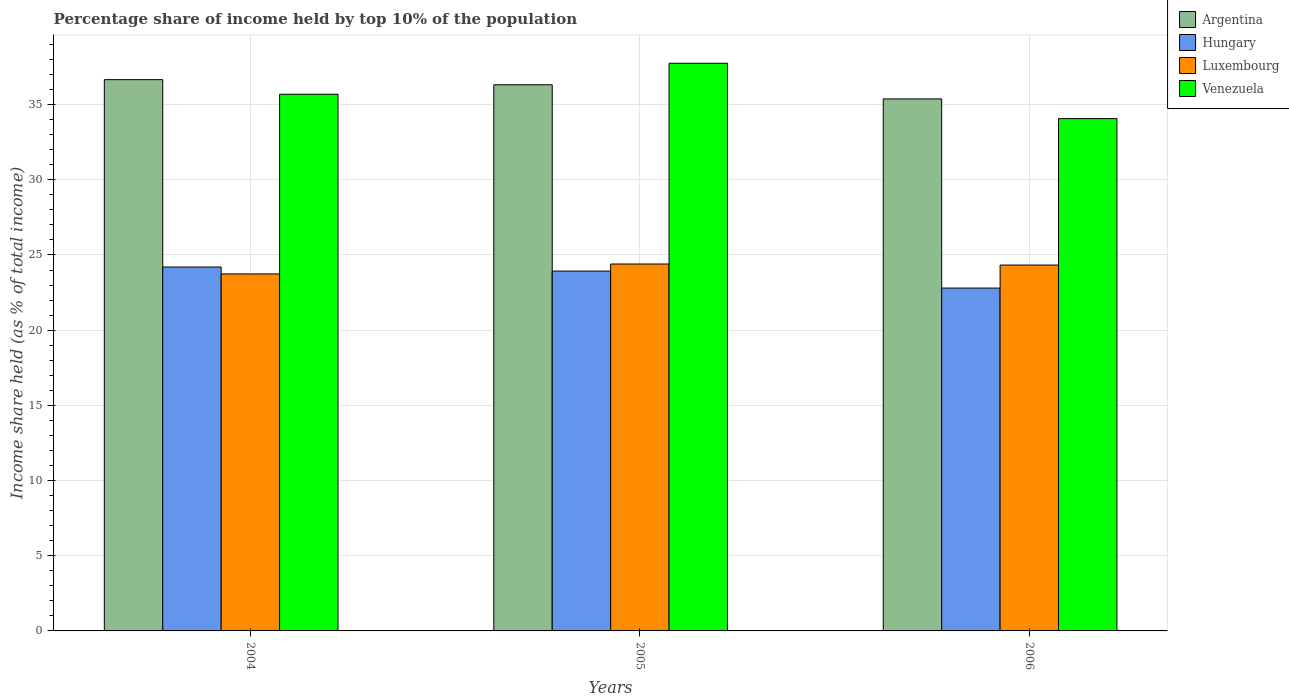How many groups of bars are there?
Provide a short and direct response. 3. Are the number of bars per tick equal to the number of legend labels?
Your response must be concise. Yes. What is the label of the 3rd group of bars from the left?
Keep it short and to the point. 2006. In how many cases, is the number of bars for a given year not equal to the number of legend labels?
Your answer should be very brief. 0. What is the percentage share of income held by top 10% of the population in Venezuela in 2004?
Ensure brevity in your answer.  35.69. Across all years, what is the maximum percentage share of income held by top 10% of the population in Hungary?
Offer a terse response. 24.2. Across all years, what is the minimum percentage share of income held by top 10% of the population in Argentina?
Ensure brevity in your answer.  35.38. What is the total percentage share of income held by top 10% of the population in Hungary in the graph?
Ensure brevity in your answer.  70.93. What is the difference between the percentage share of income held by top 10% of the population in Luxembourg in 2004 and that in 2005?
Provide a short and direct response. -0.66. What is the difference between the percentage share of income held by top 10% of the population in Venezuela in 2005 and the percentage share of income held by top 10% of the population in Hungary in 2004?
Give a very brief answer. 13.55. What is the average percentage share of income held by top 10% of the population in Hungary per year?
Your response must be concise. 23.64. In the year 2005, what is the difference between the percentage share of income held by top 10% of the population in Luxembourg and percentage share of income held by top 10% of the population in Argentina?
Give a very brief answer. -11.92. What is the ratio of the percentage share of income held by top 10% of the population in Venezuela in 2005 to that in 2006?
Provide a succinct answer. 1.11. Is the difference between the percentage share of income held by top 10% of the population in Luxembourg in 2004 and 2006 greater than the difference between the percentage share of income held by top 10% of the population in Argentina in 2004 and 2006?
Your response must be concise. No. What is the difference between the highest and the second highest percentage share of income held by top 10% of the population in Argentina?
Your answer should be compact. 0.34. What is the difference between the highest and the lowest percentage share of income held by top 10% of the population in Venezuela?
Provide a short and direct response. 3.68. In how many years, is the percentage share of income held by top 10% of the population in Argentina greater than the average percentage share of income held by top 10% of the population in Argentina taken over all years?
Your answer should be very brief. 2. Is the sum of the percentage share of income held by top 10% of the population in Venezuela in 2005 and 2006 greater than the maximum percentage share of income held by top 10% of the population in Argentina across all years?
Make the answer very short. Yes. What does the 4th bar from the left in 2006 represents?
Make the answer very short. Venezuela. What does the 2nd bar from the right in 2005 represents?
Provide a short and direct response. Luxembourg. Is it the case that in every year, the sum of the percentage share of income held by top 10% of the population in Argentina and percentage share of income held by top 10% of the population in Luxembourg is greater than the percentage share of income held by top 10% of the population in Hungary?
Give a very brief answer. Yes. Are all the bars in the graph horizontal?
Your answer should be compact. No. Does the graph contain grids?
Ensure brevity in your answer.  Yes. How many legend labels are there?
Give a very brief answer. 4. How are the legend labels stacked?
Make the answer very short. Vertical. What is the title of the graph?
Ensure brevity in your answer.  Percentage share of income held by top 10% of the population. What is the label or title of the Y-axis?
Offer a terse response. Income share held (as % of total income). What is the Income share held (as % of total income) of Argentina in 2004?
Make the answer very short. 36.66. What is the Income share held (as % of total income) in Hungary in 2004?
Offer a very short reply. 24.2. What is the Income share held (as % of total income) in Luxembourg in 2004?
Give a very brief answer. 23.74. What is the Income share held (as % of total income) in Venezuela in 2004?
Offer a very short reply. 35.69. What is the Income share held (as % of total income) in Argentina in 2005?
Provide a succinct answer. 36.32. What is the Income share held (as % of total income) of Hungary in 2005?
Provide a succinct answer. 23.93. What is the Income share held (as % of total income) in Luxembourg in 2005?
Offer a very short reply. 24.4. What is the Income share held (as % of total income) of Venezuela in 2005?
Give a very brief answer. 37.75. What is the Income share held (as % of total income) of Argentina in 2006?
Your answer should be compact. 35.38. What is the Income share held (as % of total income) in Hungary in 2006?
Provide a succinct answer. 22.8. What is the Income share held (as % of total income) in Luxembourg in 2006?
Give a very brief answer. 24.33. What is the Income share held (as % of total income) in Venezuela in 2006?
Offer a very short reply. 34.07. Across all years, what is the maximum Income share held (as % of total income) of Argentina?
Your answer should be very brief. 36.66. Across all years, what is the maximum Income share held (as % of total income) in Hungary?
Provide a succinct answer. 24.2. Across all years, what is the maximum Income share held (as % of total income) of Luxembourg?
Your response must be concise. 24.4. Across all years, what is the maximum Income share held (as % of total income) of Venezuela?
Your answer should be very brief. 37.75. Across all years, what is the minimum Income share held (as % of total income) in Argentina?
Your answer should be compact. 35.38. Across all years, what is the minimum Income share held (as % of total income) in Hungary?
Your answer should be very brief. 22.8. Across all years, what is the minimum Income share held (as % of total income) of Luxembourg?
Offer a very short reply. 23.74. Across all years, what is the minimum Income share held (as % of total income) in Venezuela?
Give a very brief answer. 34.07. What is the total Income share held (as % of total income) in Argentina in the graph?
Your answer should be very brief. 108.36. What is the total Income share held (as % of total income) of Hungary in the graph?
Offer a very short reply. 70.93. What is the total Income share held (as % of total income) in Luxembourg in the graph?
Your response must be concise. 72.47. What is the total Income share held (as % of total income) of Venezuela in the graph?
Your response must be concise. 107.51. What is the difference between the Income share held (as % of total income) in Argentina in 2004 and that in 2005?
Offer a terse response. 0.34. What is the difference between the Income share held (as % of total income) of Hungary in 2004 and that in 2005?
Give a very brief answer. 0.27. What is the difference between the Income share held (as % of total income) in Luxembourg in 2004 and that in 2005?
Provide a succinct answer. -0.66. What is the difference between the Income share held (as % of total income) of Venezuela in 2004 and that in 2005?
Your answer should be very brief. -2.06. What is the difference between the Income share held (as % of total income) of Argentina in 2004 and that in 2006?
Give a very brief answer. 1.28. What is the difference between the Income share held (as % of total income) of Luxembourg in 2004 and that in 2006?
Make the answer very short. -0.59. What is the difference between the Income share held (as % of total income) of Venezuela in 2004 and that in 2006?
Offer a very short reply. 1.62. What is the difference between the Income share held (as % of total income) of Hungary in 2005 and that in 2006?
Offer a terse response. 1.13. What is the difference between the Income share held (as % of total income) in Luxembourg in 2005 and that in 2006?
Ensure brevity in your answer.  0.07. What is the difference between the Income share held (as % of total income) of Venezuela in 2005 and that in 2006?
Make the answer very short. 3.68. What is the difference between the Income share held (as % of total income) in Argentina in 2004 and the Income share held (as % of total income) in Hungary in 2005?
Ensure brevity in your answer.  12.73. What is the difference between the Income share held (as % of total income) in Argentina in 2004 and the Income share held (as % of total income) in Luxembourg in 2005?
Your response must be concise. 12.26. What is the difference between the Income share held (as % of total income) of Argentina in 2004 and the Income share held (as % of total income) of Venezuela in 2005?
Your answer should be compact. -1.09. What is the difference between the Income share held (as % of total income) in Hungary in 2004 and the Income share held (as % of total income) in Luxembourg in 2005?
Make the answer very short. -0.2. What is the difference between the Income share held (as % of total income) in Hungary in 2004 and the Income share held (as % of total income) in Venezuela in 2005?
Provide a short and direct response. -13.55. What is the difference between the Income share held (as % of total income) of Luxembourg in 2004 and the Income share held (as % of total income) of Venezuela in 2005?
Your answer should be very brief. -14.01. What is the difference between the Income share held (as % of total income) in Argentina in 2004 and the Income share held (as % of total income) in Hungary in 2006?
Your answer should be very brief. 13.86. What is the difference between the Income share held (as % of total income) of Argentina in 2004 and the Income share held (as % of total income) of Luxembourg in 2006?
Offer a terse response. 12.33. What is the difference between the Income share held (as % of total income) in Argentina in 2004 and the Income share held (as % of total income) in Venezuela in 2006?
Provide a short and direct response. 2.59. What is the difference between the Income share held (as % of total income) of Hungary in 2004 and the Income share held (as % of total income) of Luxembourg in 2006?
Make the answer very short. -0.13. What is the difference between the Income share held (as % of total income) in Hungary in 2004 and the Income share held (as % of total income) in Venezuela in 2006?
Keep it short and to the point. -9.87. What is the difference between the Income share held (as % of total income) in Luxembourg in 2004 and the Income share held (as % of total income) in Venezuela in 2006?
Give a very brief answer. -10.33. What is the difference between the Income share held (as % of total income) of Argentina in 2005 and the Income share held (as % of total income) of Hungary in 2006?
Provide a short and direct response. 13.52. What is the difference between the Income share held (as % of total income) of Argentina in 2005 and the Income share held (as % of total income) of Luxembourg in 2006?
Offer a terse response. 11.99. What is the difference between the Income share held (as % of total income) in Argentina in 2005 and the Income share held (as % of total income) in Venezuela in 2006?
Provide a short and direct response. 2.25. What is the difference between the Income share held (as % of total income) in Hungary in 2005 and the Income share held (as % of total income) in Venezuela in 2006?
Your answer should be very brief. -10.14. What is the difference between the Income share held (as % of total income) of Luxembourg in 2005 and the Income share held (as % of total income) of Venezuela in 2006?
Give a very brief answer. -9.67. What is the average Income share held (as % of total income) of Argentina per year?
Give a very brief answer. 36.12. What is the average Income share held (as % of total income) of Hungary per year?
Your response must be concise. 23.64. What is the average Income share held (as % of total income) in Luxembourg per year?
Your answer should be compact. 24.16. What is the average Income share held (as % of total income) of Venezuela per year?
Your answer should be compact. 35.84. In the year 2004, what is the difference between the Income share held (as % of total income) in Argentina and Income share held (as % of total income) in Hungary?
Provide a short and direct response. 12.46. In the year 2004, what is the difference between the Income share held (as % of total income) of Argentina and Income share held (as % of total income) of Luxembourg?
Your response must be concise. 12.92. In the year 2004, what is the difference between the Income share held (as % of total income) in Hungary and Income share held (as % of total income) in Luxembourg?
Keep it short and to the point. 0.46. In the year 2004, what is the difference between the Income share held (as % of total income) of Hungary and Income share held (as % of total income) of Venezuela?
Ensure brevity in your answer.  -11.49. In the year 2004, what is the difference between the Income share held (as % of total income) in Luxembourg and Income share held (as % of total income) in Venezuela?
Keep it short and to the point. -11.95. In the year 2005, what is the difference between the Income share held (as % of total income) in Argentina and Income share held (as % of total income) in Hungary?
Your response must be concise. 12.39. In the year 2005, what is the difference between the Income share held (as % of total income) of Argentina and Income share held (as % of total income) of Luxembourg?
Offer a very short reply. 11.92. In the year 2005, what is the difference between the Income share held (as % of total income) of Argentina and Income share held (as % of total income) of Venezuela?
Make the answer very short. -1.43. In the year 2005, what is the difference between the Income share held (as % of total income) in Hungary and Income share held (as % of total income) in Luxembourg?
Keep it short and to the point. -0.47. In the year 2005, what is the difference between the Income share held (as % of total income) in Hungary and Income share held (as % of total income) in Venezuela?
Provide a succinct answer. -13.82. In the year 2005, what is the difference between the Income share held (as % of total income) in Luxembourg and Income share held (as % of total income) in Venezuela?
Provide a short and direct response. -13.35. In the year 2006, what is the difference between the Income share held (as % of total income) in Argentina and Income share held (as % of total income) in Hungary?
Provide a short and direct response. 12.58. In the year 2006, what is the difference between the Income share held (as % of total income) in Argentina and Income share held (as % of total income) in Luxembourg?
Offer a terse response. 11.05. In the year 2006, what is the difference between the Income share held (as % of total income) of Argentina and Income share held (as % of total income) of Venezuela?
Your answer should be very brief. 1.31. In the year 2006, what is the difference between the Income share held (as % of total income) in Hungary and Income share held (as % of total income) in Luxembourg?
Keep it short and to the point. -1.53. In the year 2006, what is the difference between the Income share held (as % of total income) in Hungary and Income share held (as % of total income) in Venezuela?
Provide a succinct answer. -11.27. In the year 2006, what is the difference between the Income share held (as % of total income) in Luxembourg and Income share held (as % of total income) in Venezuela?
Offer a terse response. -9.74. What is the ratio of the Income share held (as % of total income) in Argentina in 2004 to that in 2005?
Offer a terse response. 1.01. What is the ratio of the Income share held (as % of total income) in Hungary in 2004 to that in 2005?
Ensure brevity in your answer.  1.01. What is the ratio of the Income share held (as % of total income) in Luxembourg in 2004 to that in 2005?
Offer a very short reply. 0.97. What is the ratio of the Income share held (as % of total income) of Venezuela in 2004 to that in 2005?
Provide a succinct answer. 0.95. What is the ratio of the Income share held (as % of total income) in Argentina in 2004 to that in 2006?
Keep it short and to the point. 1.04. What is the ratio of the Income share held (as % of total income) of Hungary in 2004 to that in 2006?
Your response must be concise. 1.06. What is the ratio of the Income share held (as % of total income) of Luxembourg in 2004 to that in 2006?
Provide a succinct answer. 0.98. What is the ratio of the Income share held (as % of total income) in Venezuela in 2004 to that in 2006?
Offer a very short reply. 1.05. What is the ratio of the Income share held (as % of total income) of Argentina in 2005 to that in 2006?
Keep it short and to the point. 1.03. What is the ratio of the Income share held (as % of total income) of Hungary in 2005 to that in 2006?
Give a very brief answer. 1.05. What is the ratio of the Income share held (as % of total income) of Luxembourg in 2005 to that in 2006?
Keep it short and to the point. 1. What is the ratio of the Income share held (as % of total income) in Venezuela in 2005 to that in 2006?
Ensure brevity in your answer.  1.11. What is the difference between the highest and the second highest Income share held (as % of total income) in Argentina?
Offer a terse response. 0.34. What is the difference between the highest and the second highest Income share held (as % of total income) of Hungary?
Your answer should be very brief. 0.27. What is the difference between the highest and the second highest Income share held (as % of total income) in Luxembourg?
Provide a succinct answer. 0.07. What is the difference between the highest and the second highest Income share held (as % of total income) of Venezuela?
Ensure brevity in your answer.  2.06. What is the difference between the highest and the lowest Income share held (as % of total income) of Argentina?
Provide a short and direct response. 1.28. What is the difference between the highest and the lowest Income share held (as % of total income) in Luxembourg?
Your answer should be compact. 0.66. What is the difference between the highest and the lowest Income share held (as % of total income) of Venezuela?
Your response must be concise. 3.68. 